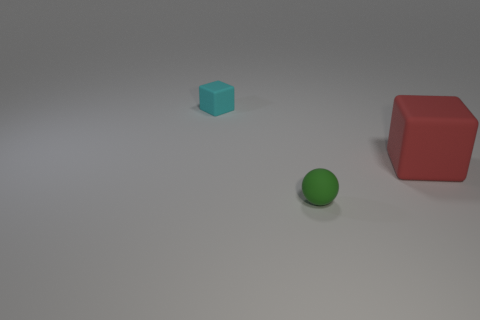Are there any cyan objects on the right side of the cube that is to the right of the cyan rubber cube?
Give a very brief answer. No. What shape is the rubber thing that is both to the left of the red thing and behind the green matte sphere?
Keep it short and to the point. Cube. What size is the cube in front of the matte cube that is to the left of the green ball?
Give a very brief answer. Large. What number of other objects are the same shape as the big object?
Your response must be concise. 1. Is there any other thing that has the same shape as the cyan rubber thing?
Offer a terse response. Yes. Are there any matte things that have the same color as the small cube?
Offer a terse response. No. Do the cube that is right of the green thing and the cube on the left side of the large object have the same material?
Ensure brevity in your answer.  Yes. What color is the large cube?
Your response must be concise. Red. How big is the rubber block to the left of the tiny object in front of the rubber object on the left side of the tiny green thing?
Provide a short and direct response. Small. How many other objects are the same size as the green thing?
Give a very brief answer. 1. 